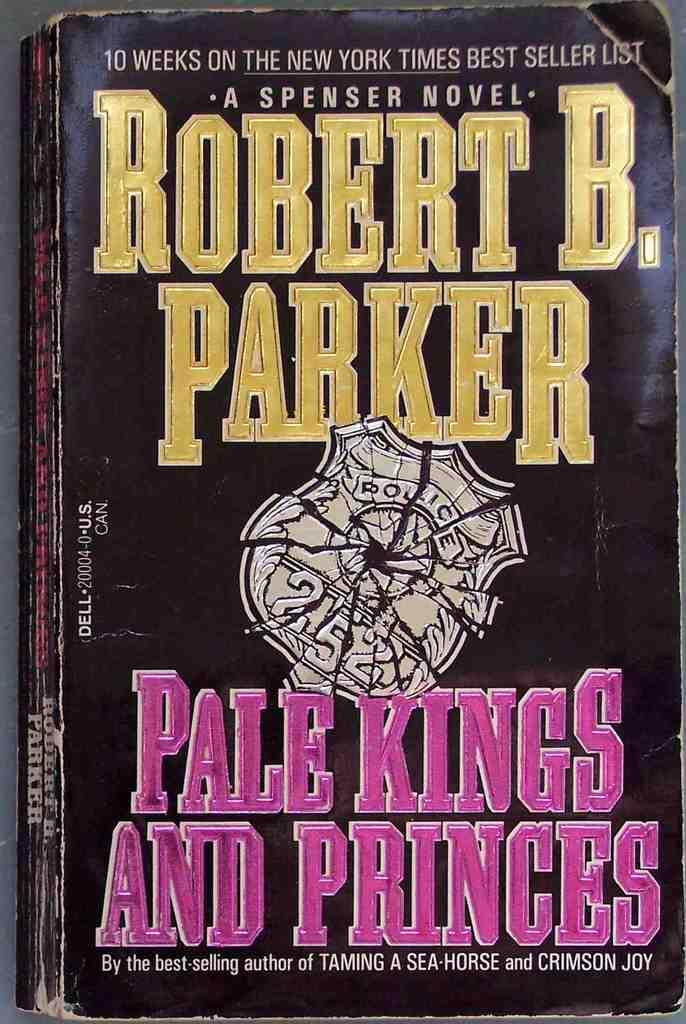<image>
Offer a succinct explanation of the picture presented. A paperback book by Robert B. Parker called "Pale Kings and Princes" 